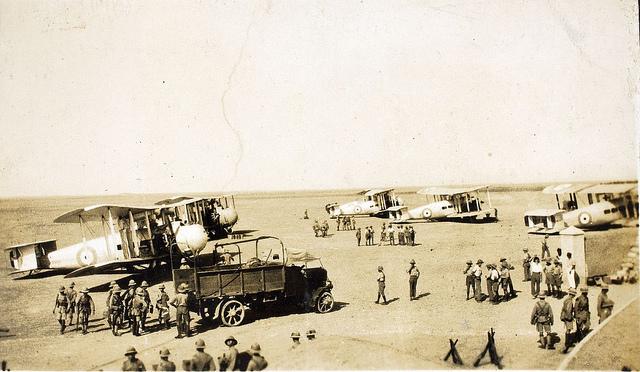Are the planes in the air?
Short answer required. No. What year is this?
Answer briefly. Unknown. Is the picture black and white?
Write a very short answer. Yes. 